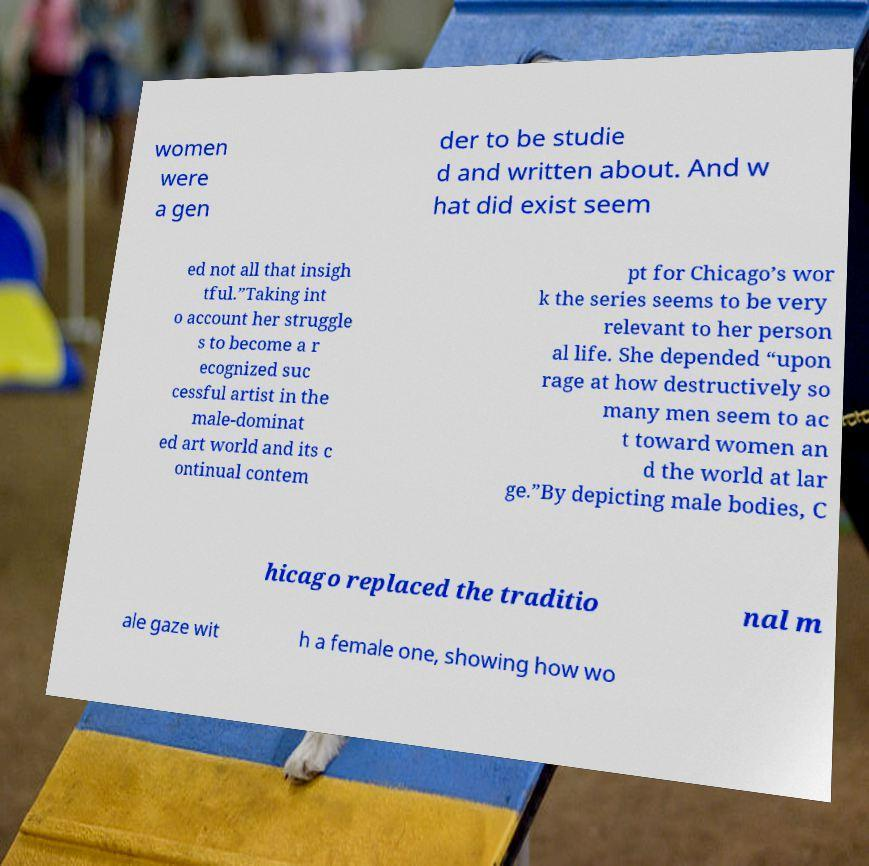Could you extract and type out the text from this image? women were a gen der to be studie d and written about. And w hat did exist seem ed not all that insigh tful.”Taking int o account her struggle s to become a r ecognized suc cessful artist in the male-dominat ed art world and its c ontinual contem pt for Chicago’s wor k the series seems to be very relevant to her person al life. She depended “upon rage at how destructively so many men seem to ac t toward women an d the world at lar ge.”By depicting male bodies, C hicago replaced the traditio nal m ale gaze wit h a female one, showing how wo 